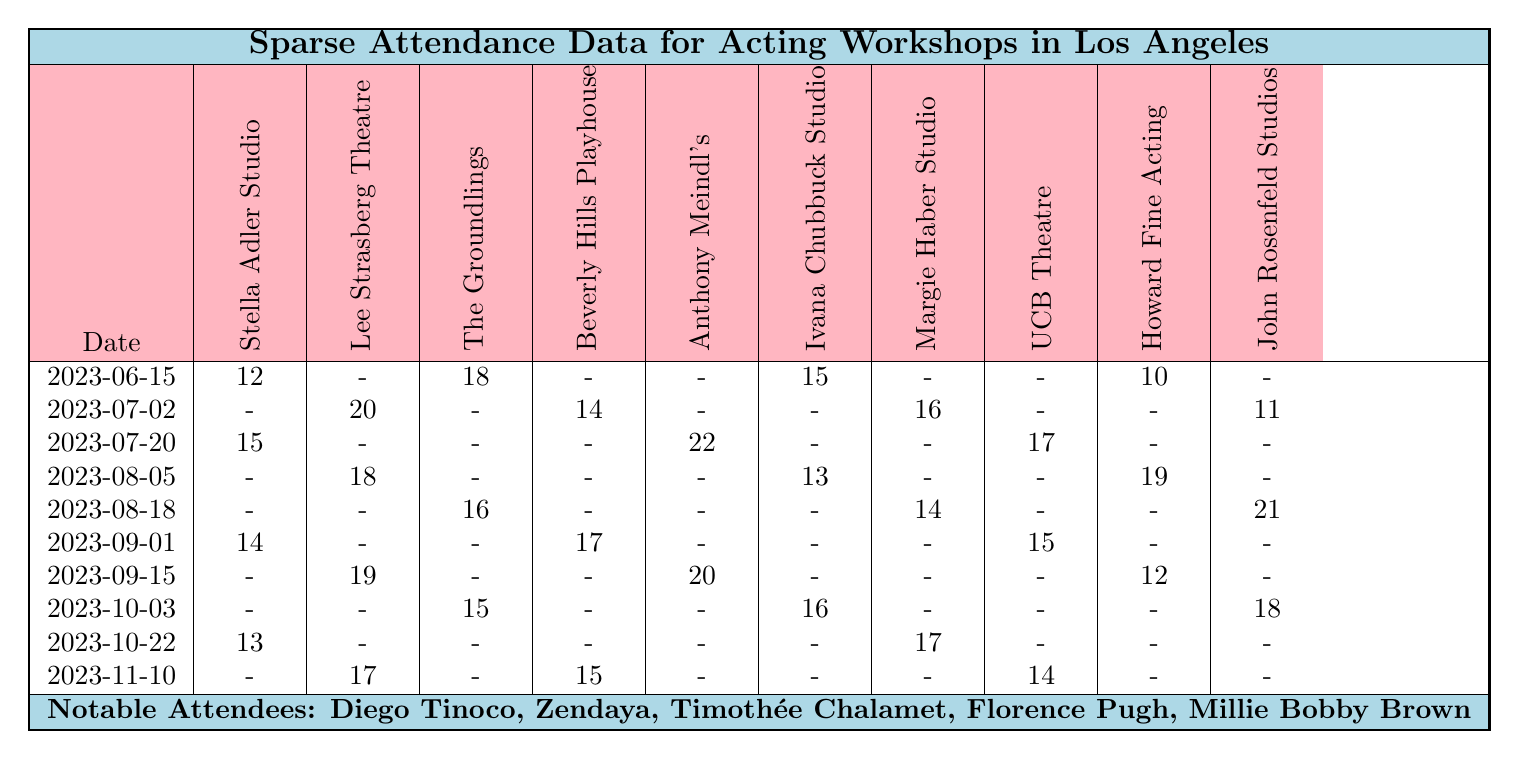What is the highest attendance recorded for any workshop on a single date? Looking through the attendance data, the maximum value is 22, which belongs to "Anthony Meindl's Actor Workshop" on the date "2023-07-20".
Answer: 22 Which workshop had the most significant attendance on 2023-09-15? For the date "2023-09-15," the attendance for "Howard Fine Acting Studio" is 12, "Lee Strasberg Theatre & Film Institute" is 19, and no other workshops had attendance. The highest attendance is 19 at "Lee Strasberg Theatre & Film Institute".
Answer: Lee Strasberg Theatre & Film Institute What is the total attendance for "Stella Adler Studio" across all dates? Adding the values from the attendance data for "Stella Adler Studio": 12 + 0 + 15 + 0 + 0 + 14 + 0 + 0 + 13 + 0 = 54.
Answer: 54 Is there any date when "The Groundlings" had zero attendance? Reviewing the attendance data, "The Groundlings" had zero attendance on 2023-06-15, 2023-07-02, 2023-07-20, 2023-08-05, 2023-09-01, 2023-09-15 and 2023-10-22, confirming multiple dates with zero attendance.
Answer: Yes How does the average attendance for "UCB Theatre" compare to "Beverly Hills Playhouse"? Calculating the average for "UCB Theatre" (attendance values: 0, 0, 17, 0, 0, 15, 0, 0, 0, 14): (0 + 0 + 17 + 0 + 0 + 15 + 0 + 0 + 0 + 14) / 10 = 4.6. Now for "Beverly Hills Playhouse" (attendance values: 0, 14, 0, 0, 0, 17, 0, 0, 0, 15): (0 + 14 + 0 + 0 + 0 + 17 + 0 + 0 + 0 + 15) / 10 = 4.6. The averages are equal.
Answer: They are the same What is the date with the highest total attendance across all workshops? By calculating the total attendance for each date: for instance, "2023-06-15" totals 55, "2023-07-02" totals 61, "2023-07-20" totals 54, "2023-08-05" totals 50, "2023-08-18" totals 51, "2023-09-01" totals 46, "2023-09-15" totals 51, "2023-10-03" totals 31, "2023-10-22" totals 30, and "2023-11-10" totals 46. The highest total attendance is 61 on "2023-07-02".
Answer: 2023-07-02 Which notable attendee attended the least number of workshops? The notable attendees listed do not correlate directly with the attendance data; however, since all noted figures are just mentions and we can't quantify their attendance based on provided data, we can say we don't have a direct answer to this.
Answer: Not applicable 